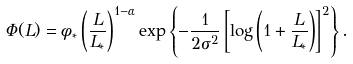Convert formula to latex. <formula><loc_0><loc_0><loc_500><loc_500>\Phi ( L ) = \phi _ { * } \left ( \frac { L } { L _ { * } } \right ) ^ { 1 - \alpha } \exp \left \{ - \frac { 1 } { 2 \sigma ^ { 2 } } \left [ \log \left ( 1 + \frac { L } { L _ { * } } \right ) \right ] ^ { 2 } \right \} .</formula> 